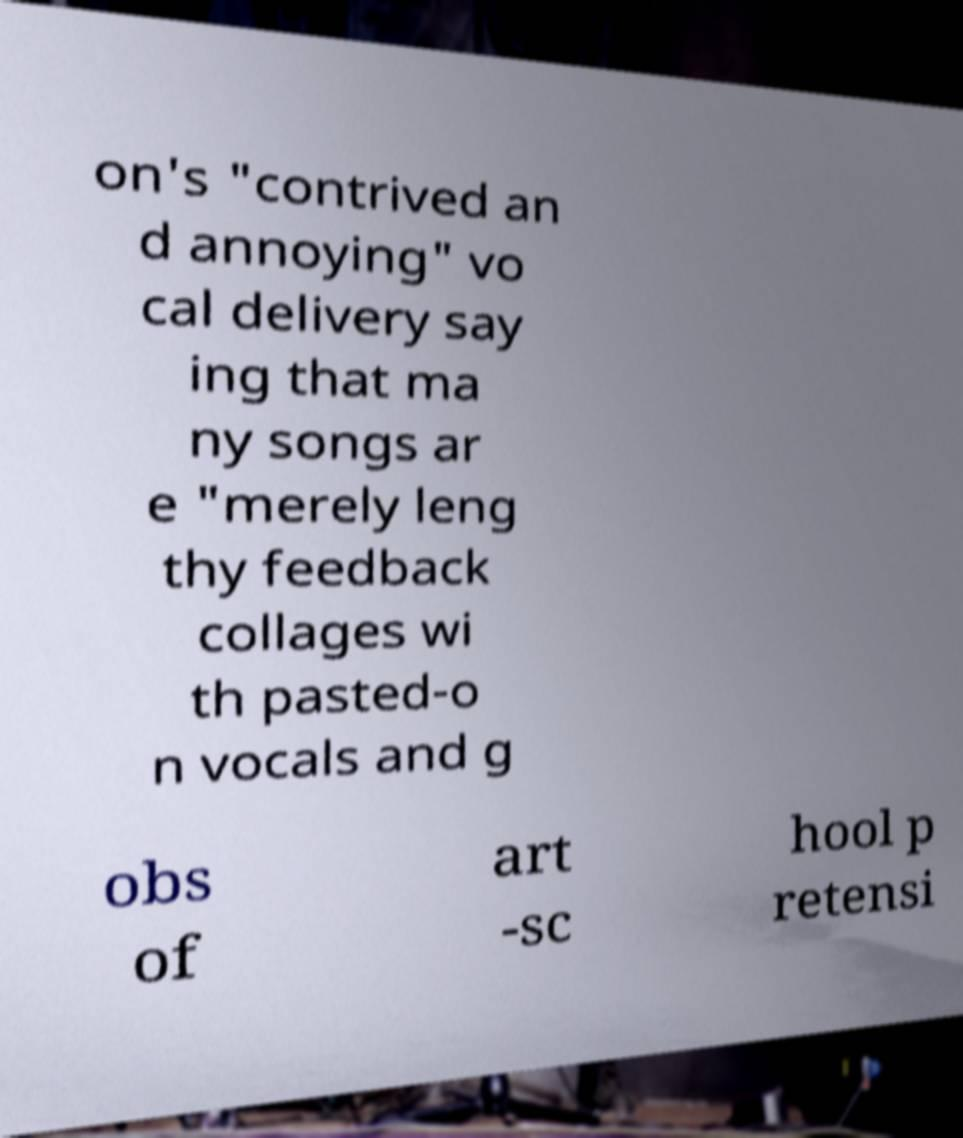Could you assist in decoding the text presented in this image and type it out clearly? on's "contrived an d annoying" vo cal delivery say ing that ma ny songs ar e "merely leng thy feedback collages wi th pasted-o n vocals and g obs of art -sc hool p retensi 